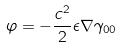<formula> <loc_0><loc_0><loc_500><loc_500>\varphi = - \frac { c ^ { 2 } } { 2 } \epsilon \nabla \gamma _ { 0 0 }</formula> 